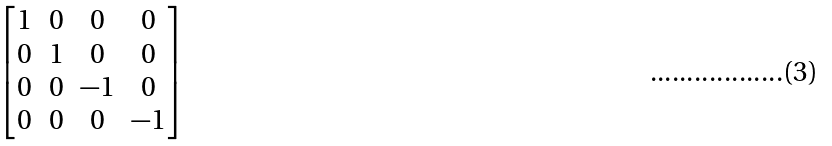Convert formula to latex. <formula><loc_0><loc_0><loc_500><loc_500>\begin{bmatrix} 1 & 0 & 0 & 0 \\ 0 & 1 & 0 & 0 \\ 0 & 0 & - 1 & 0 \\ 0 & 0 & 0 & - 1 \end{bmatrix}</formula> 